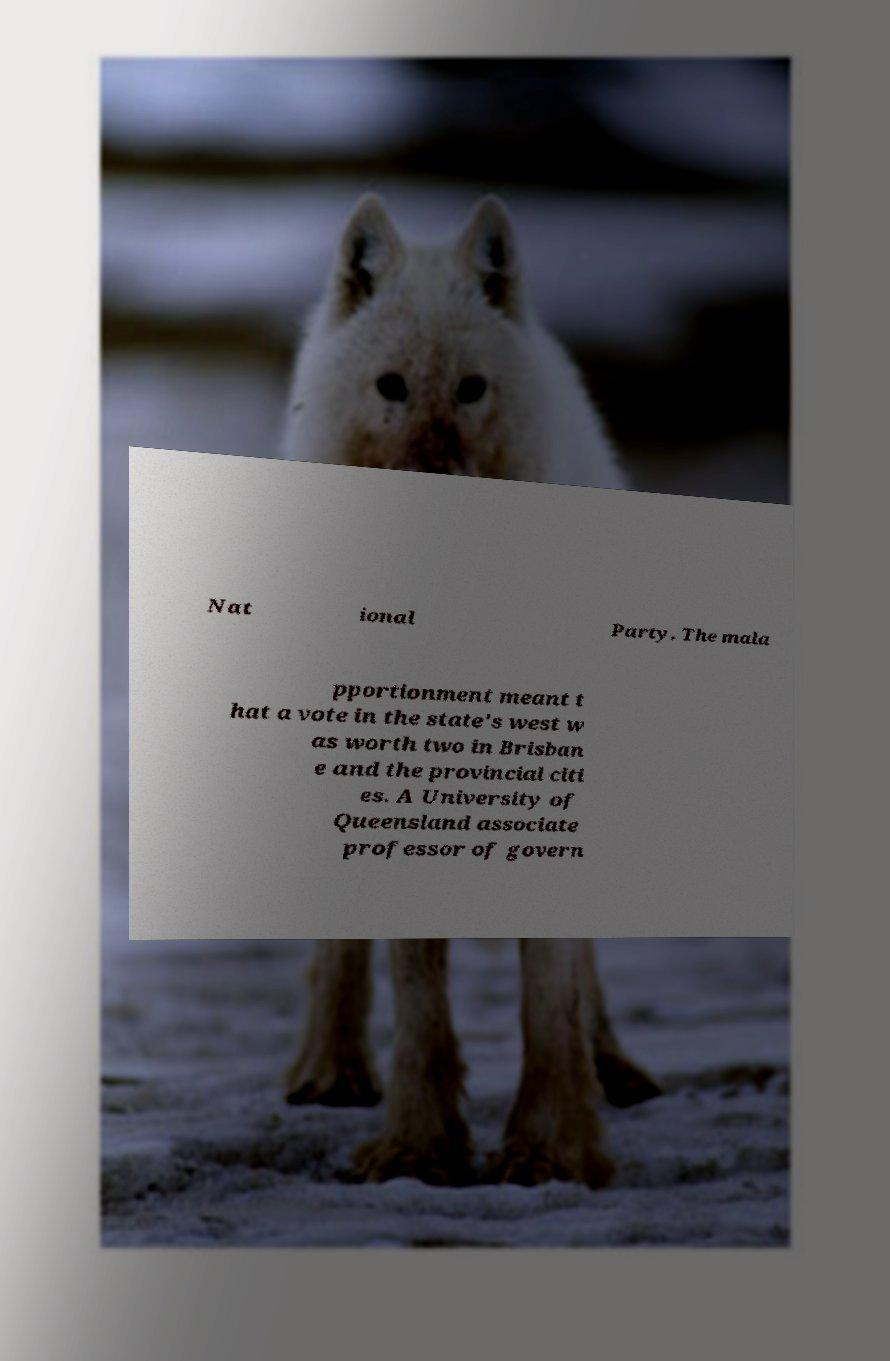I need the written content from this picture converted into text. Can you do that? Nat ional Party. The mala pportionment meant t hat a vote in the state's west w as worth two in Brisban e and the provincial citi es. A University of Queensland associate professor of govern 